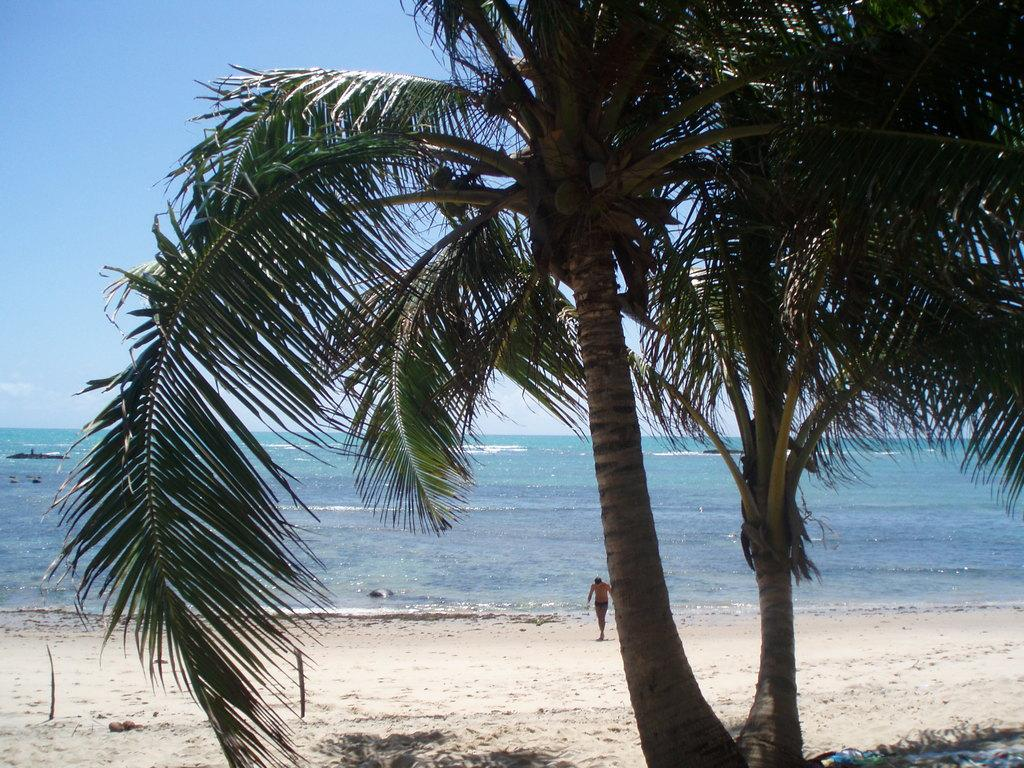What type of vegetation can be seen in the image? There are trees in the image. What is the person in the image doing? The person is on the ground in the image. What can be seen in the background of the image? There is water and the sky visible in the background of the image. What type of juice is being served at the amusement park in the image? There is no amusement park or juice present in the image. What is the person arguing about in the image? There is no argument or indication of conflict in the image. 